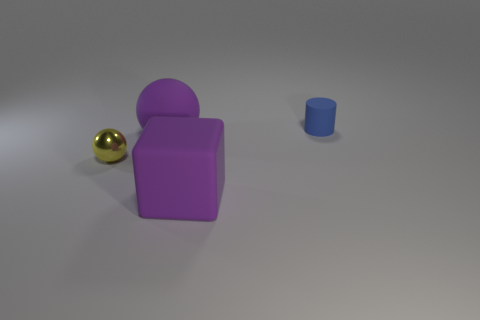What shape is the thing that is both to the right of the purple sphere and behind the small ball?
Keep it short and to the point. Cylinder. There is a object that is the same color as the large matte block; what is it made of?
Provide a succinct answer. Rubber. How many balls are large purple rubber things or small yellow metal things?
Your answer should be compact. 2. There is a object that is the same color as the rubber block; what is its size?
Provide a succinct answer. Large. Are there fewer small shiny things behind the tiny cylinder than large gray rubber blocks?
Your answer should be compact. No. There is a object that is on the right side of the metallic ball and on the left side of the matte cube; what color is it?
Give a very brief answer. Purple. How many other things are the same shape as the blue rubber object?
Make the answer very short. 0. Are there fewer large blocks to the left of the purple rubber sphere than tiny things behind the rubber block?
Give a very brief answer. Yes. Is the material of the big ball the same as the tiny thing that is to the left of the purple cube?
Offer a terse response. No. Are there any other things that have the same material as the yellow sphere?
Provide a short and direct response. No. 